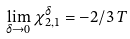<formula> <loc_0><loc_0><loc_500><loc_500>\lim _ { \delta \to 0 } \chi _ { 2 , 1 } ^ { \delta } = - 2 / 3 \, T</formula> 